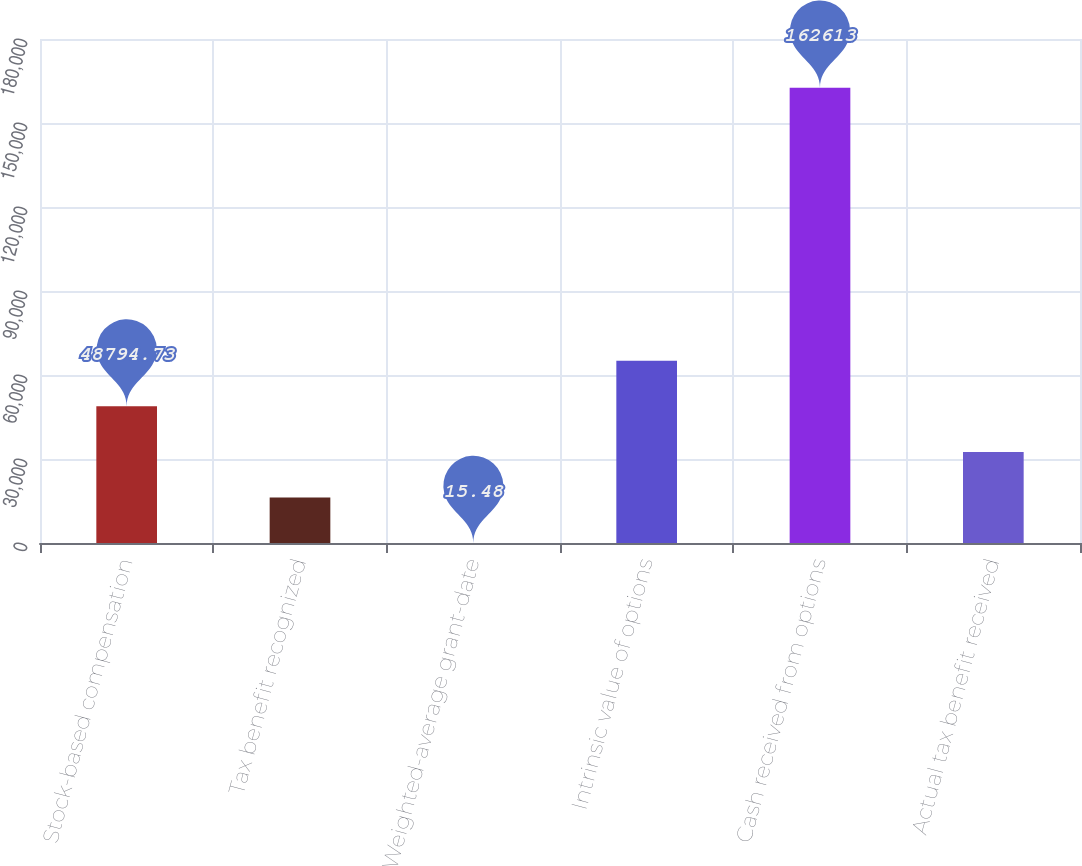Convert chart. <chart><loc_0><loc_0><loc_500><loc_500><bar_chart><fcel>Stock-based compensation<fcel>Tax benefit recognized<fcel>Weighted-average grant-date<fcel>Intrinsic value of options<fcel>Cash received from options<fcel>Actual tax benefit received<nl><fcel>48794.7<fcel>16275.2<fcel>15.48<fcel>65054.5<fcel>162613<fcel>32535<nl></chart> 